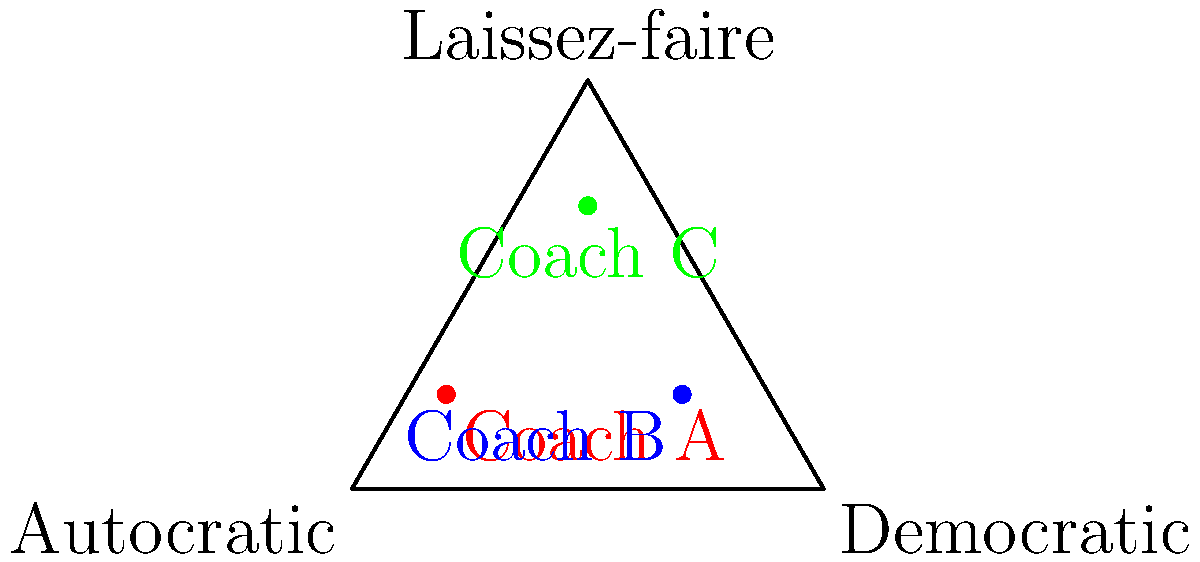In the topological data analysis of leadership styles, three coaches (A, B, and C) are plotted on a simplex representing the continuum between Autocratic, Democratic, and Laissez-faire leadership styles. Based on their positions in the simplex, which coach demonstrates the most balanced approach across all three leadership styles? To determine which coach demonstrates the most balanced approach across all three leadership styles, we need to analyze their positions within the simplex:

1. The simplex represents a continuous spectrum of leadership styles, with each vertex representing a pure form of one style:
   - Bottom left: Autocratic
   - Bottom right: Democratic
   - Top: Laissez-faire

2. A balanced approach would be represented by a point closer to the center of the simplex, indicating a mix of all three styles.

3. Let's analyze each coach's position:
   - Coach A: Located in the lower left quadrant, closer to the Autocratic vertex.
   - Coach B: Located in the lower right quadrant, closer to the Democratic vertex.
   - Coach C: Located near the center of the simplex, but slightly higher towards the Laissez-faire vertex.

4. To quantify the balance, we can roughly estimate the distance from each point to the center of the simplex:
   - The center of the simplex would be approximately at coordinates (0.5, 0.33).
   - Coach A is furthest from this center point.
   - Coach B is closer to the center than Coach A, but still favors one style (Democratic).
   - Coach C is closest to the center point.

5. Coach C's position indicates a more even distribution among the three leadership styles, as it is not strongly pulled towards any single vertex.

Therefore, based on the topological data analysis represented in the simplex, Coach C demonstrates the most balanced approach across all three leadership styles.
Answer: Coach C 